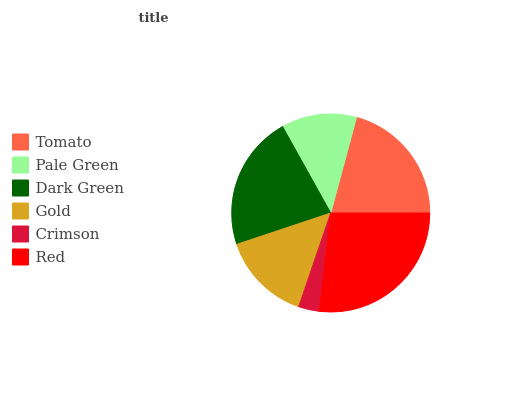Is Crimson the minimum?
Answer yes or no. Yes. Is Red the maximum?
Answer yes or no. Yes. Is Pale Green the minimum?
Answer yes or no. No. Is Pale Green the maximum?
Answer yes or no. No. Is Tomato greater than Pale Green?
Answer yes or no. Yes. Is Pale Green less than Tomato?
Answer yes or no. Yes. Is Pale Green greater than Tomato?
Answer yes or no. No. Is Tomato less than Pale Green?
Answer yes or no. No. Is Tomato the high median?
Answer yes or no. Yes. Is Gold the low median?
Answer yes or no. Yes. Is Gold the high median?
Answer yes or no. No. Is Red the low median?
Answer yes or no. No. 